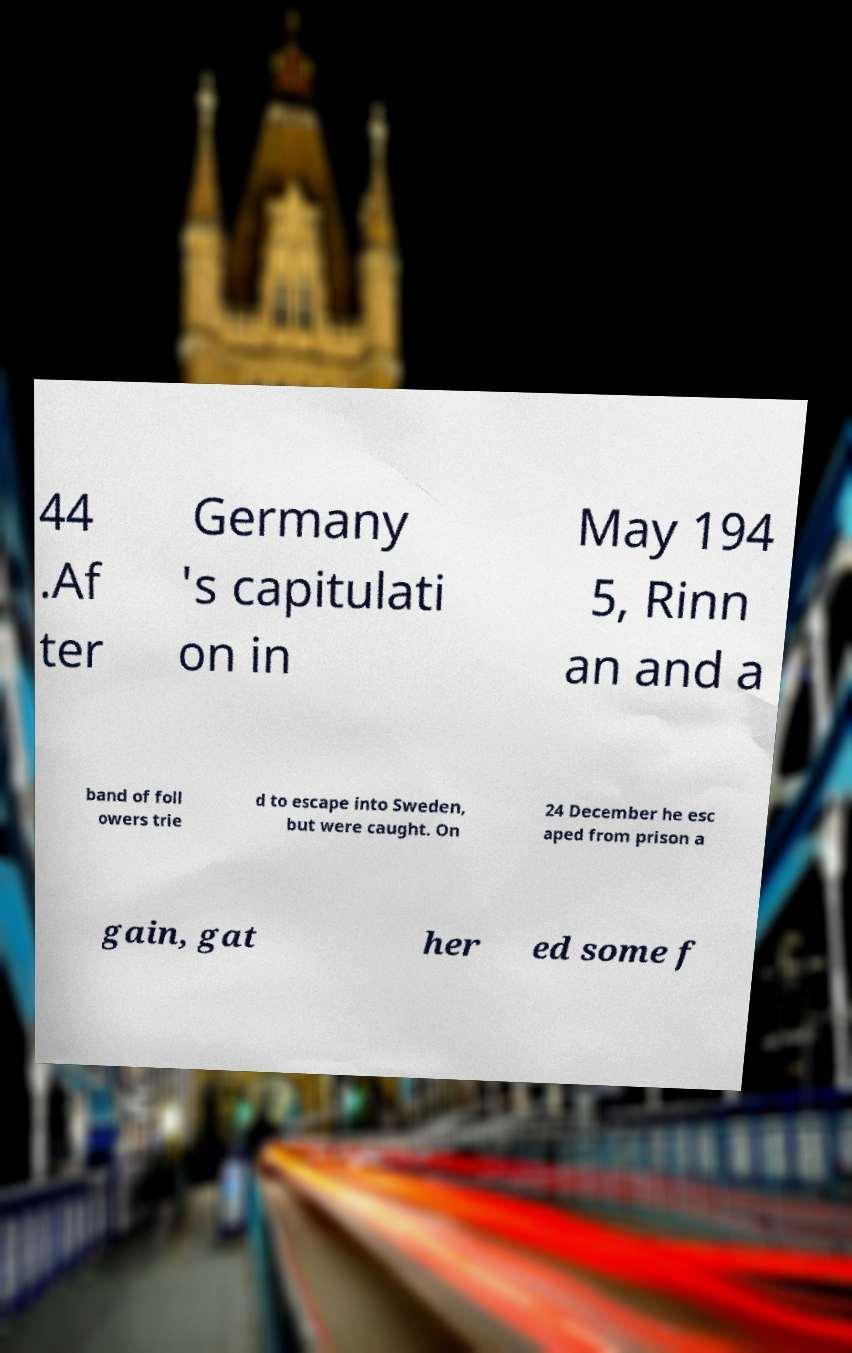Could you assist in decoding the text presented in this image and type it out clearly? 44 .Af ter Germany 's capitulati on in May 194 5, Rinn an and a band of foll owers trie d to escape into Sweden, but were caught. On 24 December he esc aped from prison a gain, gat her ed some f 